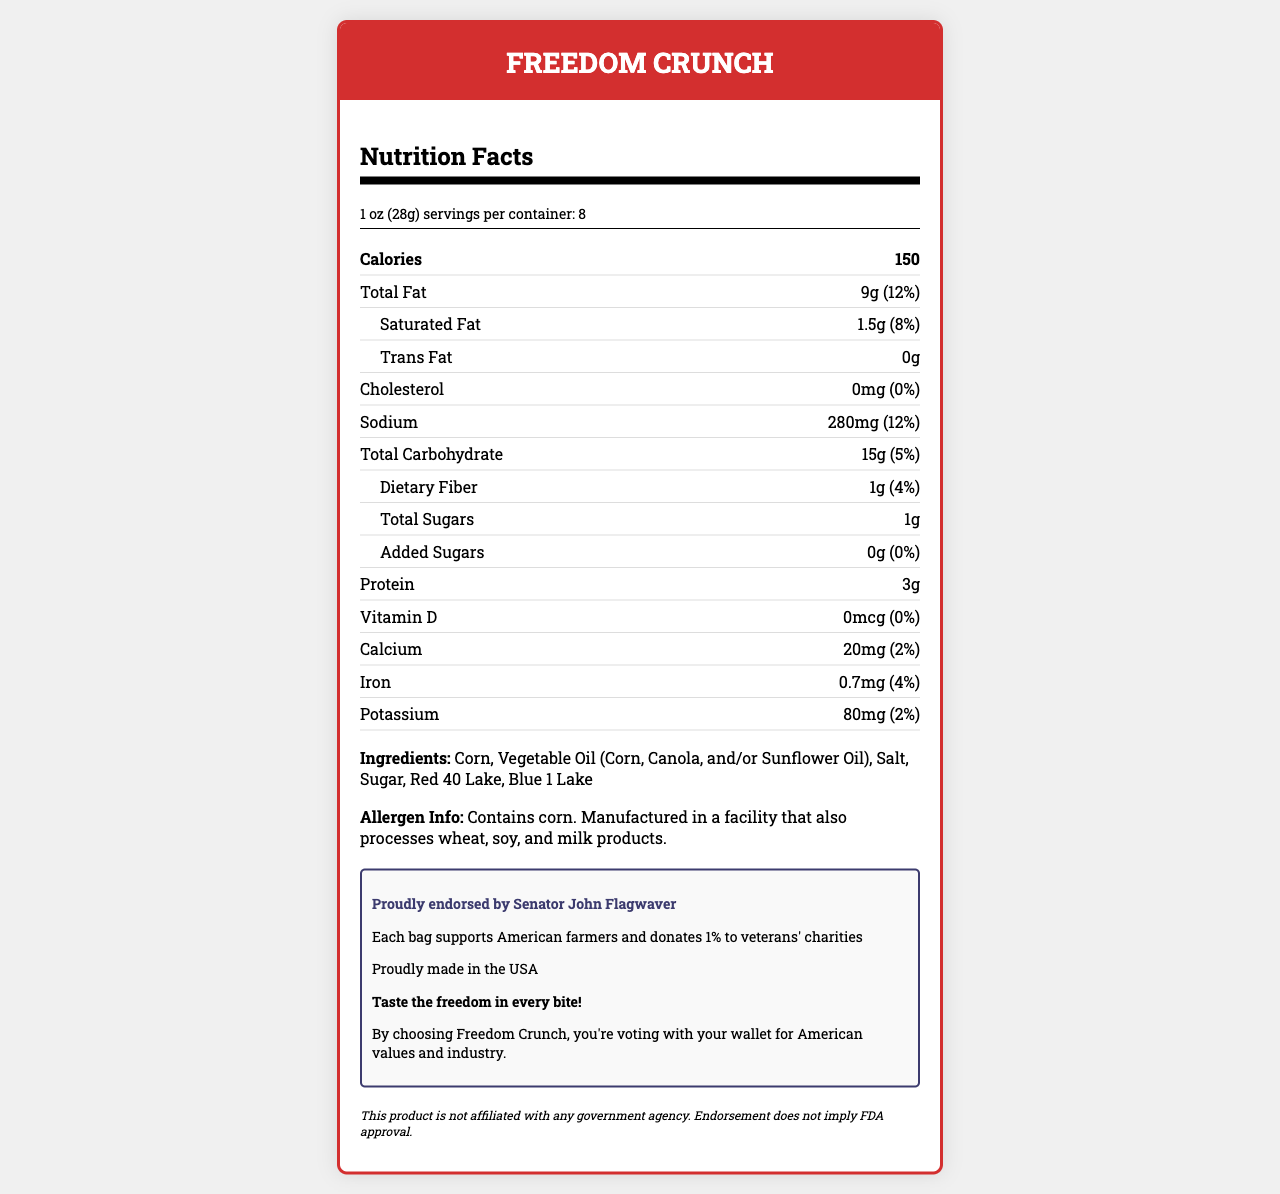what is the serving size for Freedom Crunch? The serving size is mentioned at the top of the Nutrition Facts section as "1 oz (28g)".
Answer: 1 oz (28g) how many servings are there per container? The document states "servings per container: 8" right below the serving size section.
Answer: 8 how many calories are in one serving of Freedom Crunch? The Nutrition Facts section lists calories as 150 per serving.
Answer: 150 what is the total fat content of one serving? The Nutrition Facts section shows "Total Fat 9g (12%)".
Answer: 9g (12%) how much sodium does one serving of Freedom Crunch contain? The sodium content is listed as 280mg, which is 12% of the daily value.
Answer: 280mg (12%) which ingredient does Freedom Crunch contain? A. Potato B. Corn C. Wheat D. Rice The ingredients list shows that the primary ingredient is Corn.
Answer: B how much protein is in one serving of Freedom Crunch? A. 1g B. 2g C. 3g D. 4g The Protein content is listed as 3g.
Answer: C is there any dietary fiber in Freedom Crunch? Dietary Fiber is listed in the document as 1g, which is 4% of the daily value.
Answer: Yes is the product made in the USA? The document states "Proudly made in the USA".
Answer: Yes is the product affiliated with any government agency? The controversy disclaimer mentions "This product is not affiliated with any government agency."
Answer: No what minerals are present in Freedom Crunch? The Nutrition Facts section lists Calcium (20mg), Iron (0.7mg), and Potassium (80mg).
Answer: Calcium, Iron, Potassium who endorses the Freedom Crunch product? The document states "Proudly endorsed by Senator John Flagwaver".
Answer: Senator John Flagwaver what is the patriotic claim made by Freedom Crunch? This claim is included in the section labeled as patriotic.
Answer: Each bag supports American farmers and donates 1% to veterans' charities does Freedom Crunch contain any trans fat? The Nutrition Facts section states "Trans Fat 0g".
Answer: No summarize the entire document. The document offers comprehensive information on the nutritional content, ingredients, endorsements, and patriotic claims for the Freedom Crunch product, emphasizing its support for American values and industry.
Answer: The document provides the Nutrition Facts for a product called Freedom Crunch, including serving size, calorie information, and detailed nutrient content. It lists ingredients, allergen information, and endorsements. The product claims to support American farmers and veterans and highlights its patriotic themes. It is made in the USA and is endorsed by a political figure, Senator John Flagwaver. There's a disclaimer noting the product is not affiliated with any government agency. how much vitamin D does one serving of Freedom Crunch contain? The Nutrition Facts section lists "Vitamin D 0mcg (0%)".
Answer: 0mcg (0%) can Freedom Crunch be considered low in cholesterol? The document states that the cholesterol content is 0mg, which is 0% of the daily value.
Answer: Yes what are the sources of vegetable oil in Freedom Crunch? The ingredients section lists Vegetable Oil as being made from Corn, Canola, and/or Sunflower Oil.
Answer: Corn, Canola, and/or Sunflower Oil what is the significance of the red and blue colors in the ingredients? The document does not provide information about the significance of Red 40 Lake and Blue 1 Lake in the ingredients.
Answer: Cannot be determined what is the campaign slogan for Freedom Crunch? The document includes the campaign slogan under the patriotic section as "Taste the freedom in every bite!".
Answer: Taste the freedom in every bite! what percentage of the daily value of saturated fat does one serving of Freedom Crunch contain? The Nutrition Facts section shows "Saturated Fat 1.5g (8%)".
Answer: 8% does the endorsement by Senator John Flagwaver imply FDA approval? The controversy disclaimer states "Endorsement does not imply FDA approval."
Answer: No 